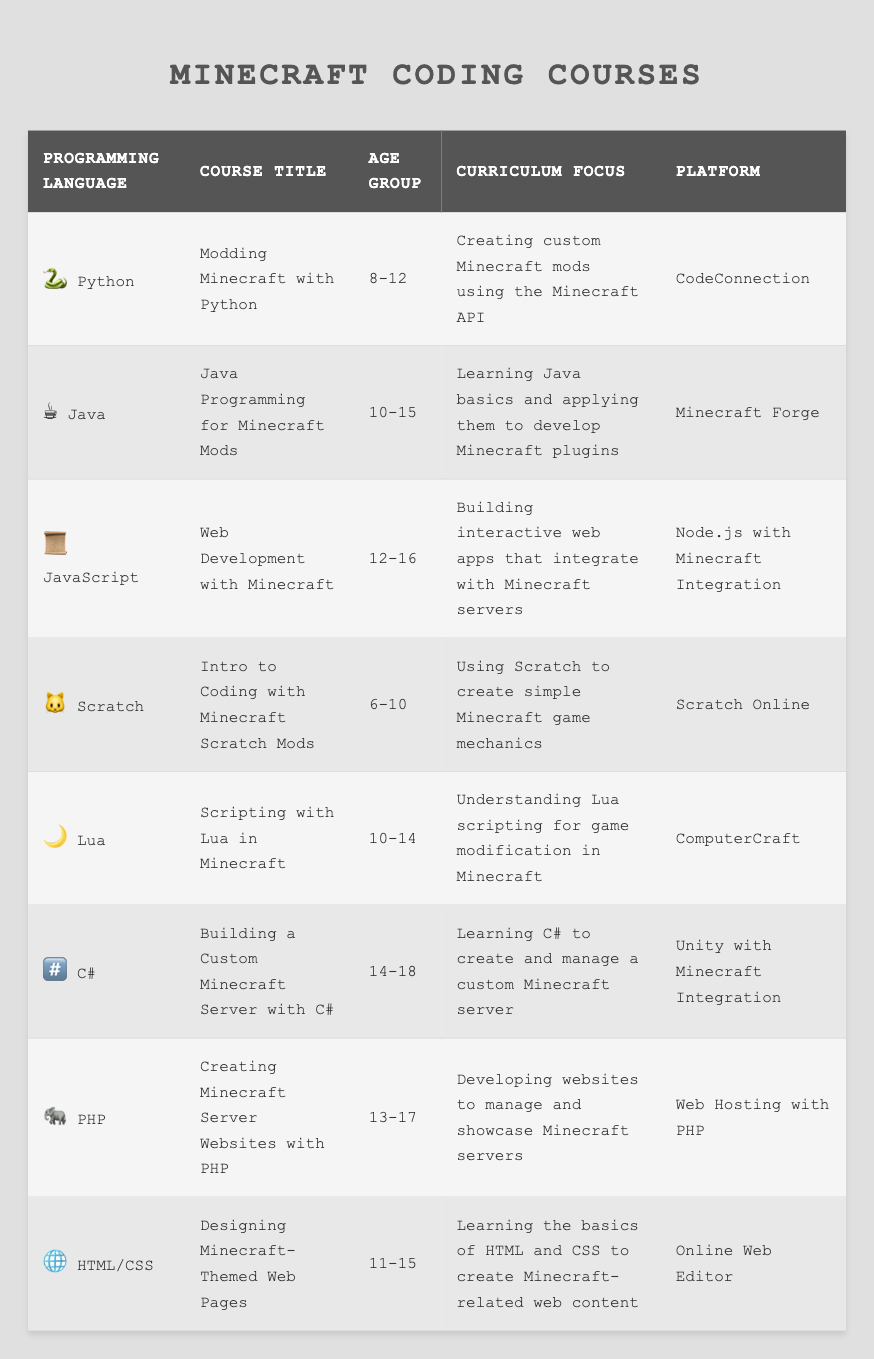What programming languages are taught in courses for ages 8-12? By examining the table, I see two courses offered for the age group 8-12: "Modding Minecraft with Python" and "Intro to Coding with Minecraft Scratch Mods." The corresponding programming languages are Python and Scratch.
Answer: Python, Scratch How many different programming languages are listed in the table? The table lists 8 different programming languages: Python, Java, JavaScript, Scratch, Lua, C#, PHP, and HTML/CSS. Therefore, the total count is 8.
Answer: 8 Is there a course specifically for the programming language C#? Looking at the table, there is a course titled "Building a Custom Minecraft Server with C#." This confirms that a course specifically for C# exists.
Answer: Yes What is the age group for the course "Web Development with Minecraft"? The age group for this course, as indicated in the table, is 12-16.
Answer: 12-16 Which programming language is used to create simple Minecraft game mechanics? The course "Intro to Coding with Minecraft Scratch Mods" focuses on using Scratch to create simple game mechanics in Minecraft, which points to Scratch as the programming language used.
Answer: Scratch What is the platform for the course "Creating Minecraft Server Websites with PHP"? The table specifies that the platform for this course is "Web Hosting with PHP."
Answer: Web Hosting with PHP Which course has the oldest age group and what is the focus? The course titled "Building a Custom Minecraft Server with C#" has the oldest age group of 14-18, and its focus is on learning C# to create and manage a custom Minecraft server.
Answer: Building a Custom Minecraft Server with C# Are there more courses focusing on Java than on Python? The table shows one course each for Python ("Modding Minecraft with Python") and Java ("Java Programming for Minecraft Mods"). Therefore, there are not more courses focused on Java than on Python; they are equal.
Answer: No What curriculum focus do most courses related to Minecraft have? By reviewing the curriculum focuses in the table, they range from creating custom mods to building web apps and Minecraft server management, but the most common theme is using programming languages to enhance gameplay. There is no single "most" focus, but all relate to Minecraft modifications or integration.
Answer: Minecraft modifications or integration If we average the minimum and maximum age groups of the courses, what would it be? The minimum age is 6 from the Scratch course and the maximum is 18 from the C# course. To find the average, we add 6 and 18 to get 24, then divide by 2. The average age is 24/2 = 12.
Answer: 12 